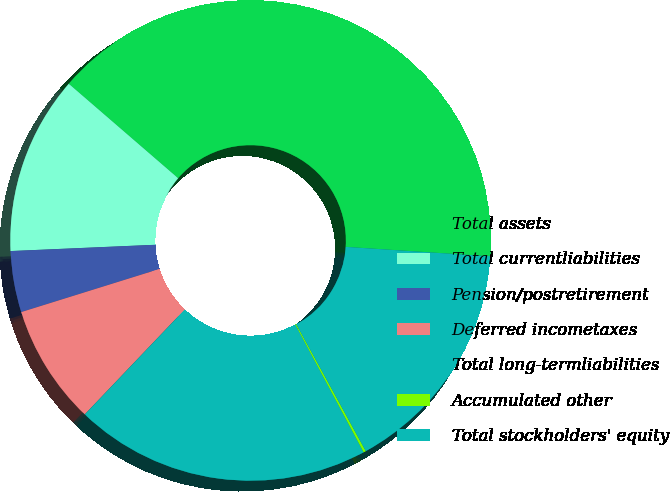Convert chart to OTSL. <chart><loc_0><loc_0><loc_500><loc_500><pie_chart><fcel>Total assets<fcel>Total currentliabilities<fcel>Pension/postretirement<fcel>Deferred incometaxes<fcel>Total long-termliabilities<fcel>Accumulated other<fcel>Total stockholders' equity<nl><fcel>39.71%<fcel>12.03%<fcel>4.12%<fcel>8.07%<fcel>19.94%<fcel>0.16%<fcel>15.98%<nl></chart> 